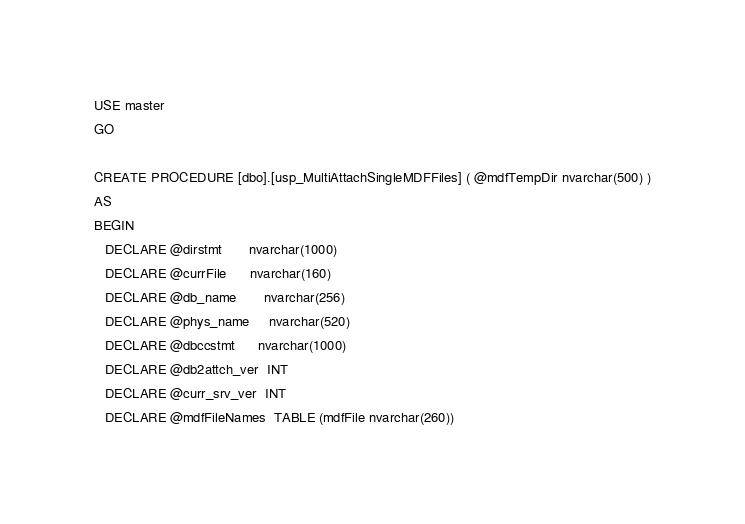Convert code to text. <code><loc_0><loc_0><loc_500><loc_500><_SQL_>USE master
GO
 
CREATE PROCEDURE [dbo].[usp_MultiAttachSingleMDFFiles] ( @mdfTempDir nvarchar(500) )
AS
BEGIN  
   DECLARE @dirstmt       nvarchar(1000)
   DECLARE @currFile      nvarchar(160)
   DECLARE @db_name       nvarchar(256)
   DECLARE @phys_name     nvarchar(520)
   DECLARE @dbccstmt      nvarchar(1000)
   DECLARE @db2attch_ver  INT
   DECLARE @curr_srv_ver  INT  
   DECLARE @mdfFileNames  TABLE (mdfFile nvarchar(260))</code> 